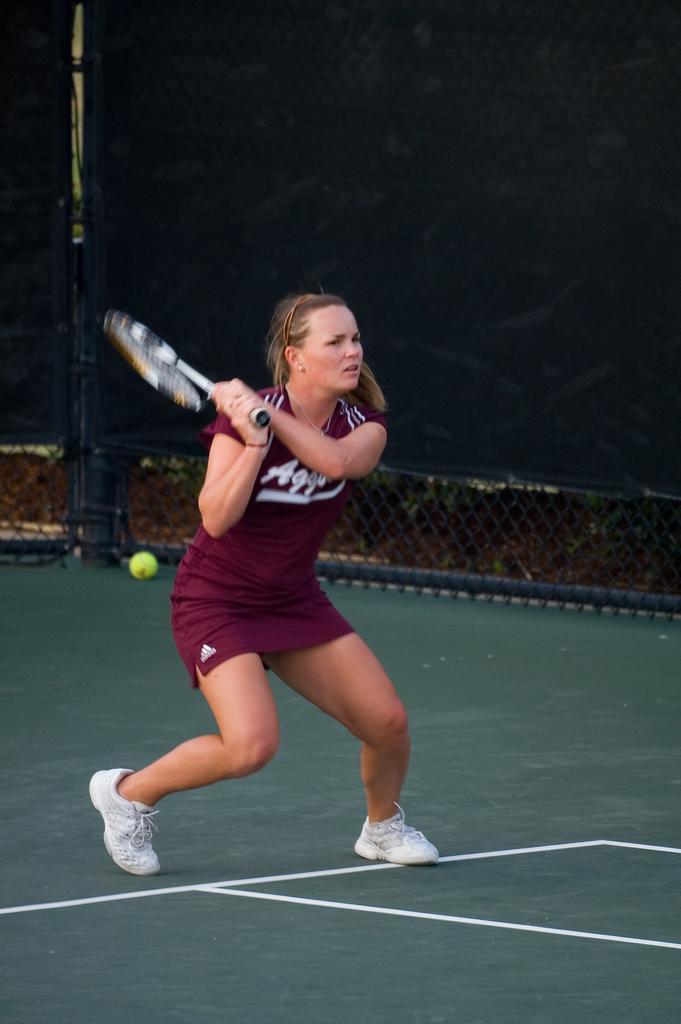How would you summarize this image in a sentence or two? It's a tennis court. A woman is playing tennis,It's a tennis ball and tennis racket. She wear a T-Shirt and a shoe. 